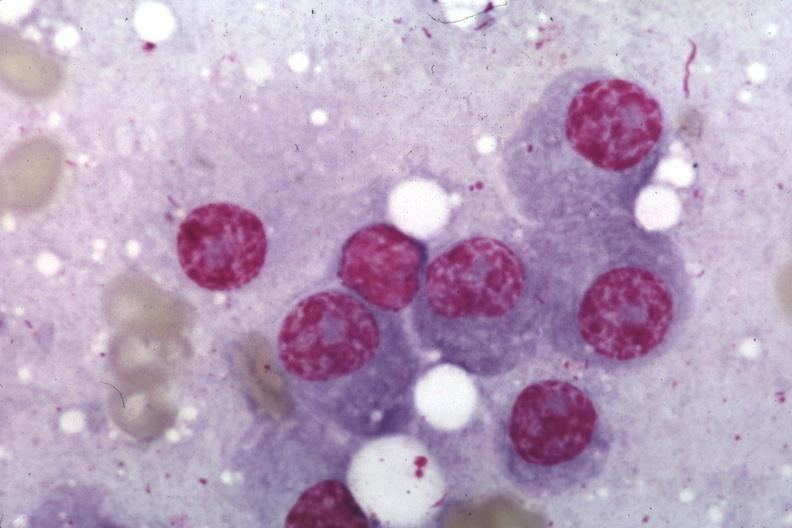s multiple myeloma present?
Answer the question using a single word or phrase. Yes 